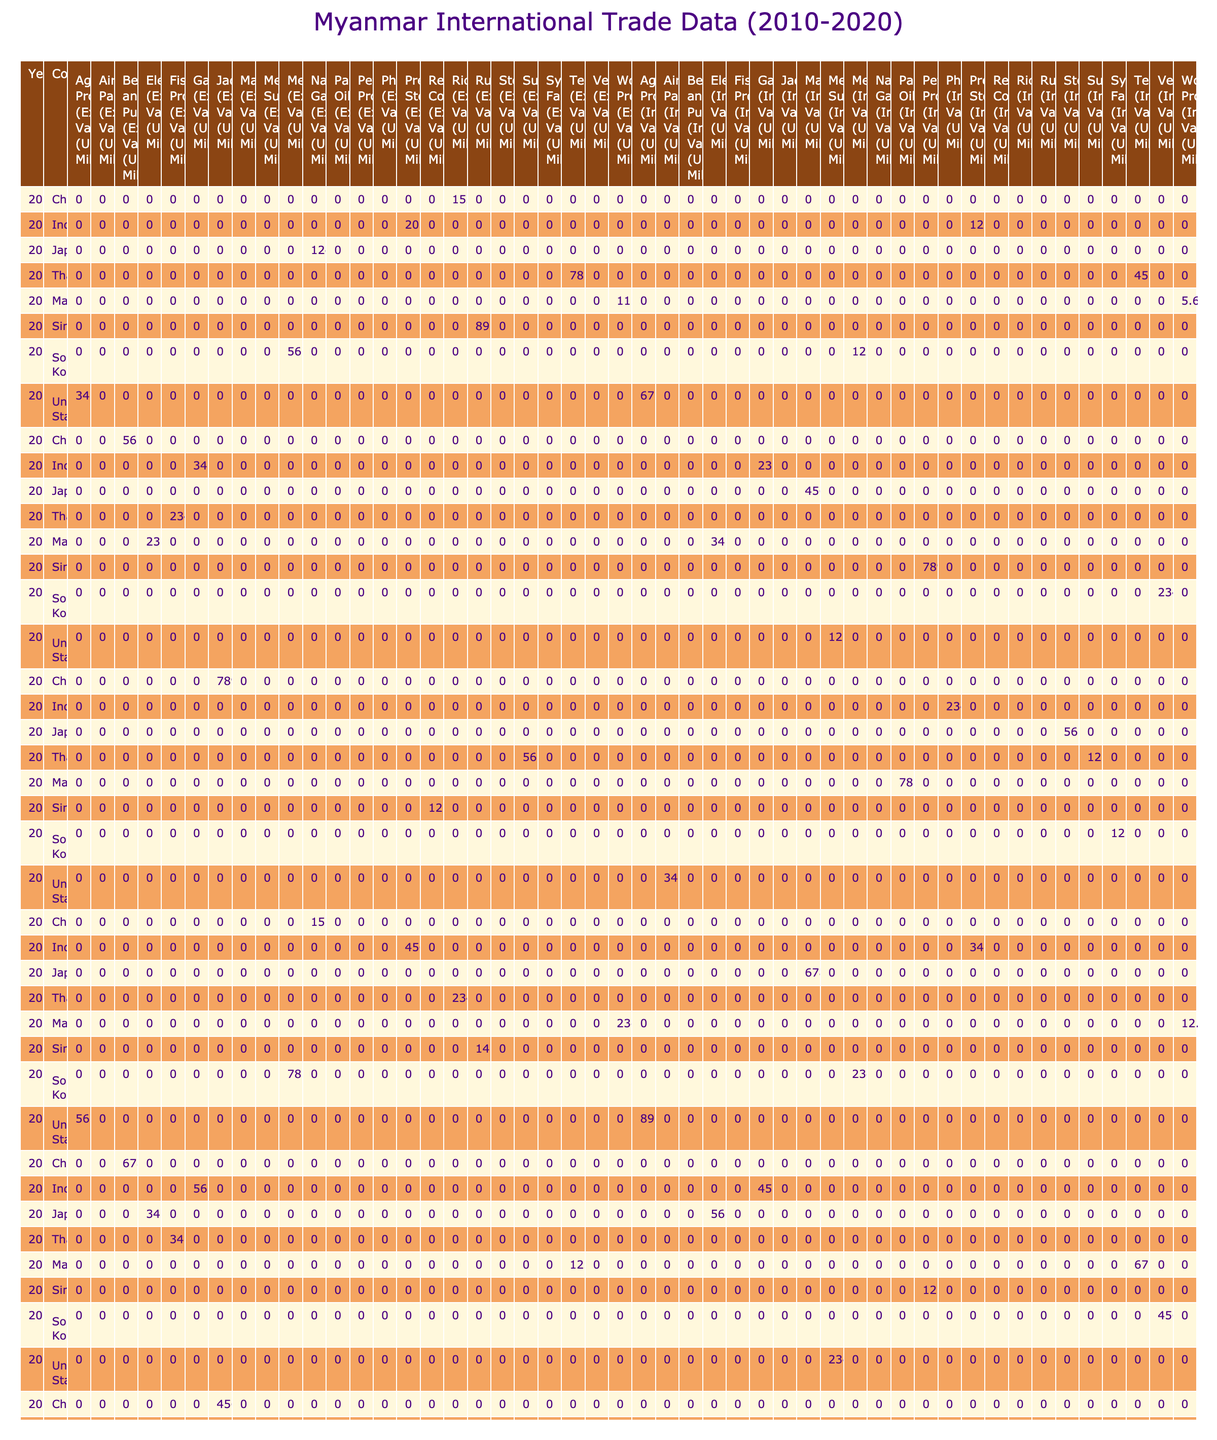What was the total export value of Agricultural Products in 2011? In 2011, the export value of Agricultural Products was 34.5 million USD. This is found directly in the corresponding cell under the Year 2011 and Country United States.
Answer: 34.5 million USD Which country imported more value of Metals in 2016, Myanmar or South Korea? South Korea imported 234.5 million USD worth of Vehicles in 2016, while Metals for the same year showed 78.9 million USD for South Korea. Since the question asks for comparison, we see that the import value for South Korea is higher when considering the specific category.
Answer: South Korea What was the average import value of Textiles over the years listed? There are two instances of Textiles: in 2010, the import value was 45.2 million USD, and in 2019, it was 67.8 million USD. Thus, the average can be calculated as (45.2 + 67.8) / 2 which equals 56.5 million USD.
Answer: 56.5 million USD Did the export value of Natural Gas change from 2010 to 2016? Looking at the data, in 2010 the export value for Natural Gas was 1245.6 million USD, and by 2016 it increased to 1567.8 million USD. Since the export value increased, the answer is yes.
Answer: Yes Which commodity had the highest export value in 2014? To find this, we look at the export values for that year. The values are: Jade (789.5 million USD for China), Sugar (56.7 million USD for Thailand), Pharmaceuticals (0), and Steel (0). The highest value is from Jade exported to China.
Answer: Jade What is the total import value of Pharmaceutical products throughout the years? The only import value for Pharmaceuticals is from India in 2014 with a value of 234.5 million USD and from India again in 2020 with a value of 345.6 million USD. Therefore, the total is 234.5 + 345.6 = 580.1 million USD.
Answer: 580.1 million USD Which country saw a decline in the import value of machinery from 2012 to 2016? In 2012, Japan exported 0 million USD worth of machinery to Myanmar. In 2016, the import value from Japan remained the same at 0 million USD. There was no increase or decrease. Hence, it can be stated there was no change.
Answer: No change What was the overall trend for export values from 2010 to 2020? By examining the table, we look at the export values over the years for key commodities. There is evident growth in some commodities like Natural Gas (2010 to 2016) but fluctuations across other years and countries. The overall trend is an upward swing with some variations in terms of specific years and commodities.
Answer: Overall upward trend with fluctuations Did the export of Beans and Pulses increase from 2012 to 2018? The data shows that in 2012, the export value for Beans and Pulses to China was 567.8 million USD, while in 2018, it rose significantly to 678.9 million USD. This indicates an increase over the years.
Answer: Yes 